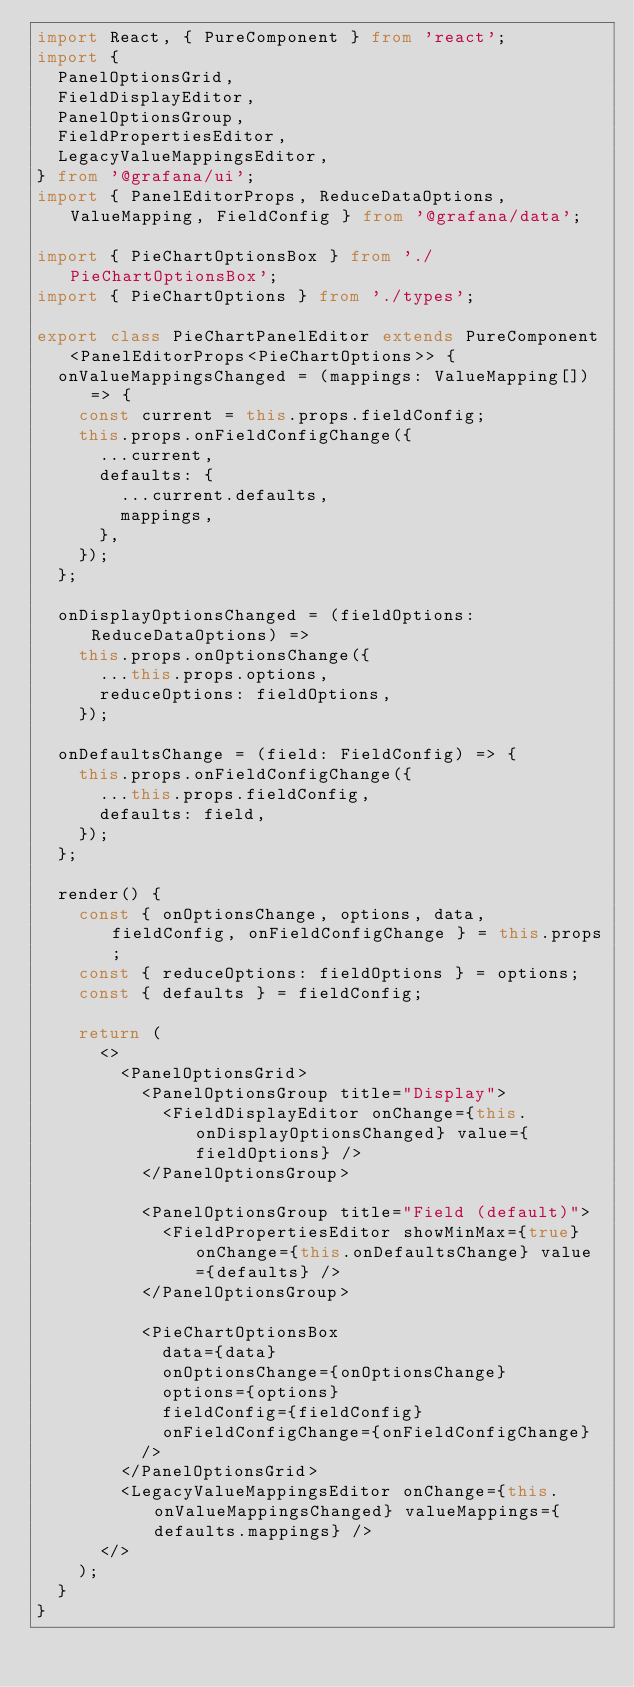<code> <loc_0><loc_0><loc_500><loc_500><_TypeScript_>import React, { PureComponent } from 'react';
import {
  PanelOptionsGrid,
  FieldDisplayEditor,
  PanelOptionsGroup,
  FieldPropertiesEditor,
  LegacyValueMappingsEditor,
} from '@grafana/ui';
import { PanelEditorProps, ReduceDataOptions, ValueMapping, FieldConfig } from '@grafana/data';

import { PieChartOptionsBox } from './PieChartOptionsBox';
import { PieChartOptions } from './types';

export class PieChartPanelEditor extends PureComponent<PanelEditorProps<PieChartOptions>> {
  onValueMappingsChanged = (mappings: ValueMapping[]) => {
    const current = this.props.fieldConfig;
    this.props.onFieldConfigChange({
      ...current,
      defaults: {
        ...current.defaults,
        mappings,
      },
    });
  };

  onDisplayOptionsChanged = (fieldOptions: ReduceDataOptions) =>
    this.props.onOptionsChange({
      ...this.props.options,
      reduceOptions: fieldOptions,
    });

  onDefaultsChange = (field: FieldConfig) => {
    this.props.onFieldConfigChange({
      ...this.props.fieldConfig,
      defaults: field,
    });
  };

  render() {
    const { onOptionsChange, options, data, fieldConfig, onFieldConfigChange } = this.props;
    const { reduceOptions: fieldOptions } = options;
    const { defaults } = fieldConfig;

    return (
      <>
        <PanelOptionsGrid>
          <PanelOptionsGroup title="Display">
            <FieldDisplayEditor onChange={this.onDisplayOptionsChanged} value={fieldOptions} />
          </PanelOptionsGroup>

          <PanelOptionsGroup title="Field (default)">
            <FieldPropertiesEditor showMinMax={true} onChange={this.onDefaultsChange} value={defaults} />
          </PanelOptionsGroup>

          <PieChartOptionsBox
            data={data}
            onOptionsChange={onOptionsChange}
            options={options}
            fieldConfig={fieldConfig}
            onFieldConfigChange={onFieldConfigChange}
          />
        </PanelOptionsGrid>
        <LegacyValueMappingsEditor onChange={this.onValueMappingsChanged} valueMappings={defaults.mappings} />
      </>
    );
  }
}
</code> 